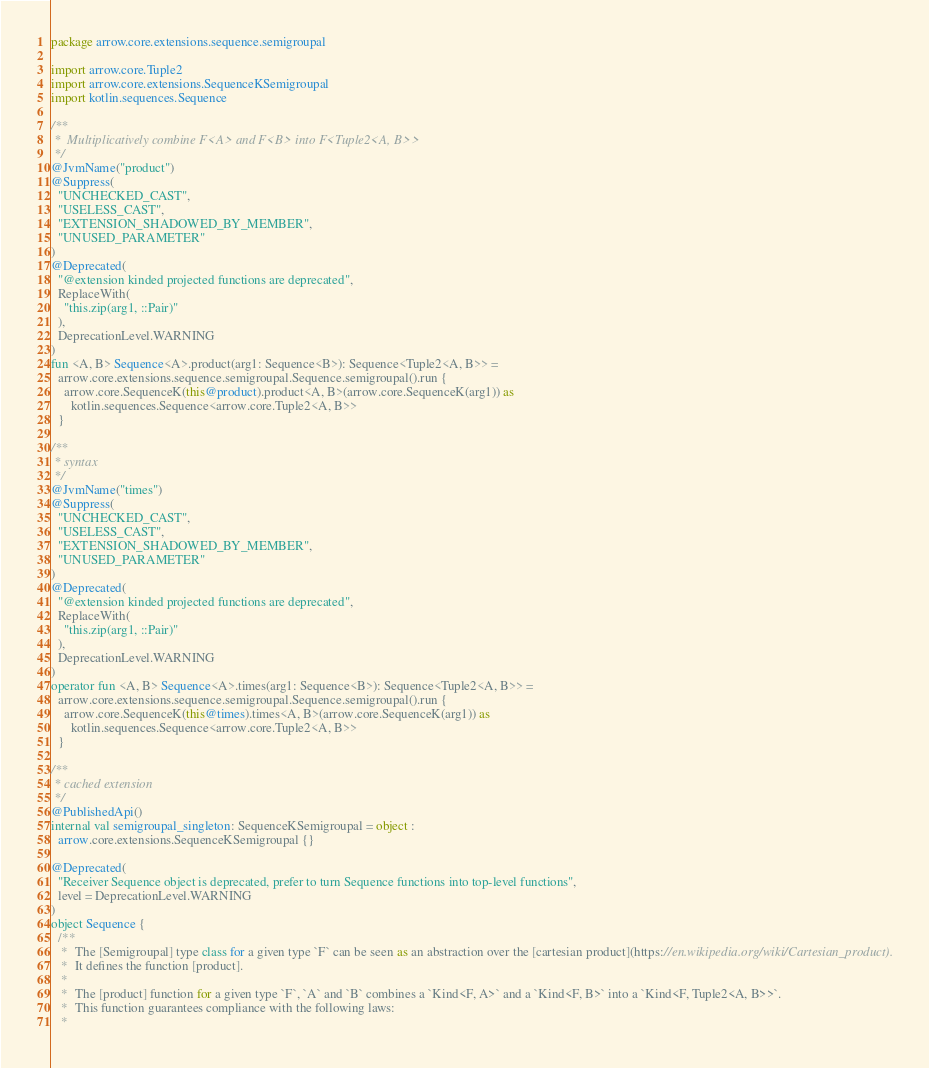Convert code to text. <code><loc_0><loc_0><loc_500><loc_500><_Kotlin_>package arrow.core.extensions.sequence.semigroupal

import arrow.core.Tuple2
import arrow.core.extensions.SequenceKSemigroupal
import kotlin.sequences.Sequence

/**
 *  Multiplicatively combine F<A> and F<B> into F<Tuple2<A, B>>
 */
@JvmName("product")
@Suppress(
  "UNCHECKED_CAST",
  "USELESS_CAST",
  "EXTENSION_SHADOWED_BY_MEMBER",
  "UNUSED_PARAMETER"
)
@Deprecated(
  "@extension kinded projected functions are deprecated",
  ReplaceWith(
    "this.zip(arg1, ::Pair)"
  ),
  DeprecationLevel.WARNING
)
fun <A, B> Sequence<A>.product(arg1: Sequence<B>): Sequence<Tuple2<A, B>> =
  arrow.core.extensions.sequence.semigroupal.Sequence.semigroupal().run {
    arrow.core.SequenceK(this@product).product<A, B>(arrow.core.SequenceK(arg1)) as
      kotlin.sequences.Sequence<arrow.core.Tuple2<A, B>>
  }

/**
 * syntax
 */
@JvmName("times")
@Suppress(
  "UNCHECKED_CAST",
  "USELESS_CAST",
  "EXTENSION_SHADOWED_BY_MEMBER",
  "UNUSED_PARAMETER"
)
@Deprecated(
  "@extension kinded projected functions are deprecated",
  ReplaceWith(
    "this.zip(arg1, ::Pair)"
  ),
  DeprecationLevel.WARNING
)
operator fun <A, B> Sequence<A>.times(arg1: Sequence<B>): Sequence<Tuple2<A, B>> =
  arrow.core.extensions.sequence.semigroupal.Sequence.semigroupal().run {
    arrow.core.SequenceK(this@times).times<A, B>(arrow.core.SequenceK(arg1)) as
      kotlin.sequences.Sequence<arrow.core.Tuple2<A, B>>
  }

/**
 * cached extension
 */
@PublishedApi()
internal val semigroupal_singleton: SequenceKSemigroupal = object :
  arrow.core.extensions.SequenceKSemigroupal {}

@Deprecated(
  "Receiver Sequence object is deprecated, prefer to turn Sequence functions into top-level functions",
  level = DeprecationLevel.WARNING
)
object Sequence {
  /**
   *  The [Semigroupal] type class for a given type `F` can be seen as an abstraction over the [cartesian product](https://en.wikipedia.org/wiki/Cartesian_product).
   *  It defines the function [product].
   *
   *  The [product] function for a given type `F`, `A` and `B` combines a `Kind<F, A>` and a `Kind<F, B>` into a `Kind<F, Tuple2<A, B>>`.
   *  This function guarantees compliance with the following laws:
   *</code> 